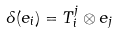<formula> <loc_0><loc_0><loc_500><loc_500>\delta ( e _ { i } ) = T _ { i } ^ { j } \otimes e _ { j }</formula> 